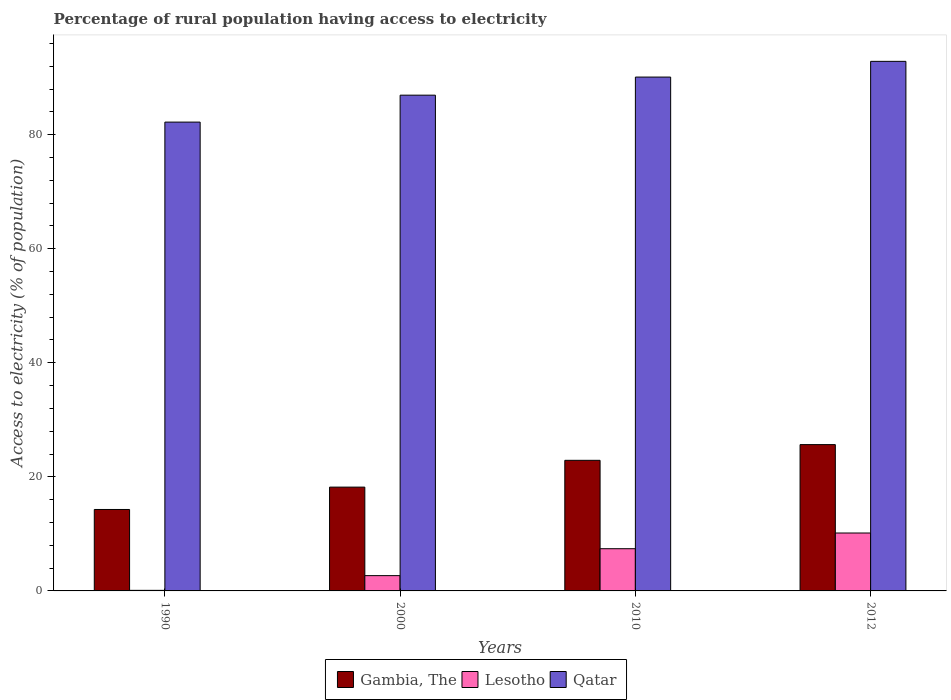How many bars are there on the 2nd tick from the left?
Offer a terse response. 3. How many bars are there on the 4th tick from the right?
Give a very brief answer. 3. Across all years, what is the maximum percentage of rural population having access to electricity in Qatar?
Offer a terse response. 92.85. Across all years, what is the minimum percentage of rural population having access to electricity in Qatar?
Ensure brevity in your answer.  82.2. In which year was the percentage of rural population having access to electricity in Lesotho maximum?
Keep it short and to the point. 2012. In which year was the percentage of rural population having access to electricity in Qatar minimum?
Keep it short and to the point. 1990. What is the total percentage of rural population having access to electricity in Gambia, The in the graph?
Give a very brief answer. 81.03. What is the difference between the percentage of rural population having access to electricity in Gambia, The in 2000 and that in 2010?
Your answer should be compact. -4.7. What is the difference between the percentage of rural population having access to electricity in Gambia, The in 2000 and the percentage of rural population having access to electricity in Lesotho in 2010?
Provide a succinct answer. 10.8. What is the average percentage of rural population having access to electricity in Gambia, The per year?
Ensure brevity in your answer.  20.26. In the year 1990, what is the difference between the percentage of rural population having access to electricity in Qatar and percentage of rural population having access to electricity in Gambia, The?
Offer a very short reply. 67.92. What is the ratio of the percentage of rural population having access to electricity in Lesotho in 1990 to that in 2010?
Your answer should be very brief. 0.01. Is the difference between the percentage of rural population having access to electricity in Qatar in 1990 and 2010 greater than the difference between the percentage of rural population having access to electricity in Gambia, The in 1990 and 2010?
Give a very brief answer. Yes. What is the difference between the highest and the second highest percentage of rural population having access to electricity in Qatar?
Provide a succinct answer. 2.75. What is the difference between the highest and the lowest percentage of rural population having access to electricity in Qatar?
Your answer should be very brief. 10.65. In how many years, is the percentage of rural population having access to electricity in Gambia, The greater than the average percentage of rural population having access to electricity in Gambia, The taken over all years?
Your answer should be compact. 2. What does the 1st bar from the left in 2012 represents?
Keep it short and to the point. Gambia, The. What does the 1st bar from the right in 2000 represents?
Make the answer very short. Qatar. Is it the case that in every year, the sum of the percentage of rural population having access to electricity in Lesotho and percentage of rural population having access to electricity in Qatar is greater than the percentage of rural population having access to electricity in Gambia, The?
Your answer should be very brief. Yes. How many bars are there?
Make the answer very short. 12. Does the graph contain grids?
Provide a short and direct response. No. Where does the legend appear in the graph?
Provide a short and direct response. Bottom center. What is the title of the graph?
Your answer should be very brief. Percentage of rural population having access to electricity. Does "Chad" appear as one of the legend labels in the graph?
Offer a terse response. No. What is the label or title of the Y-axis?
Make the answer very short. Access to electricity (% of population). What is the Access to electricity (% of population) of Gambia, The in 1990?
Ensure brevity in your answer.  14.28. What is the Access to electricity (% of population) of Lesotho in 1990?
Provide a succinct answer. 0.1. What is the Access to electricity (% of population) in Qatar in 1990?
Your response must be concise. 82.2. What is the Access to electricity (% of population) in Gambia, The in 2000?
Keep it short and to the point. 18.2. What is the Access to electricity (% of population) in Lesotho in 2000?
Your answer should be compact. 2.68. What is the Access to electricity (% of population) of Qatar in 2000?
Make the answer very short. 86.93. What is the Access to electricity (% of population) of Gambia, The in 2010?
Give a very brief answer. 22.9. What is the Access to electricity (% of population) in Lesotho in 2010?
Provide a succinct answer. 7.4. What is the Access to electricity (% of population) in Qatar in 2010?
Make the answer very short. 90.1. What is the Access to electricity (% of population) in Gambia, The in 2012?
Ensure brevity in your answer.  25.65. What is the Access to electricity (% of population) of Lesotho in 2012?
Offer a terse response. 10.15. What is the Access to electricity (% of population) of Qatar in 2012?
Your answer should be compact. 92.85. Across all years, what is the maximum Access to electricity (% of population) of Gambia, The?
Give a very brief answer. 25.65. Across all years, what is the maximum Access to electricity (% of population) in Lesotho?
Provide a succinct answer. 10.15. Across all years, what is the maximum Access to electricity (% of population) in Qatar?
Your answer should be very brief. 92.85. Across all years, what is the minimum Access to electricity (% of population) in Gambia, The?
Provide a short and direct response. 14.28. Across all years, what is the minimum Access to electricity (% of population) of Lesotho?
Offer a very short reply. 0.1. Across all years, what is the minimum Access to electricity (% of population) of Qatar?
Ensure brevity in your answer.  82.2. What is the total Access to electricity (% of population) of Gambia, The in the graph?
Keep it short and to the point. 81.03. What is the total Access to electricity (% of population) in Lesotho in the graph?
Keep it short and to the point. 20.34. What is the total Access to electricity (% of population) of Qatar in the graph?
Ensure brevity in your answer.  352.08. What is the difference between the Access to electricity (% of population) of Gambia, The in 1990 and that in 2000?
Keep it short and to the point. -3.92. What is the difference between the Access to electricity (% of population) in Lesotho in 1990 and that in 2000?
Ensure brevity in your answer.  -2.58. What is the difference between the Access to electricity (% of population) of Qatar in 1990 and that in 2000?
Ensure brevity in your answer.  -4.72. What is the difference between the Access to electricity (% of population) of Gambia, The in 1990 and that in 2010?
Your response must be concise. -8.62. What is the difference between the Access to electricity (% of population) in Qatar in 1990 and that in 2010?
Your answer should be compact. -7.9. What is the difference between the Access to electricity (% of population) in Gambia, The in 1990 and that in 2012?
Keep it short and to the point. -11.38. What is the difference between the Access to electricity (% of population) in Lesotho in 1990 and that in 2012?
Keep it short and to the point. -10.05. What is the difference between the Access to electricity (% of population) in Qatar in 1990 and that in 2012?
Your answer should be compact. -10.65. What is the difference between the Access to electricity (% of population) in Gambia, The in 2000 and that in 2010?
Offer a terse response. -4.7. What is the difference between the Access to electricity (% of population) of Lesotho in 2000 and that in 2010?
Ensure brevity in your answer.  -4.72. What is the difference between the Access to electricity (% of population) in Qatar in 2000 and that in 2010?
Keep it short and to the point. -3.17. What is the difference between the Access to electricity (% of population) of Gambia, The in 2000 and that in 2012?
Make the answer very short. -7.45. What is the difference between the Access to electricity (% of population) of Lesotho in 2000 and that in 2012?
Offer a very short reply. -7.47. What is the difference between the Access to electricity (% of population) of Qatar in 2000 and that in 2012?
Provide a short and direct response. -5.93. What is the difference between the Access to electricity (% of population) of Gambia, The in 2010 and that in 2012?
Provide a short and direct response. -2.75. What is the difference between the Access to electricity (% of population) of Lesotho in 2010 and that in 2012?
Make the answer very short. -2.75. What is the difference between the Access to electricity (% of population) of Qatar in 2010 and that in 2012?
Offer a very short reply. -2.75. What is the difference between the Access to electricity (% of population) of Gambia, The in 1990 and the Access to electricity (% of population) of Lesotho in 2000?
Give a very brief answer. 11.6. What is the difference between the Access to electricity (% of population) of Gambia, The in 1990 and the Access to electricity (% of population) of Qatar in 2000?
Give a very brief answer. -72.65. What is the difference between the Access to electricity (% of population) of Lesotho in 1990 and the Access to electricity (% of population) of Qatar in 2000?
Ensure brevity in your answer.  -86.83. What is the difference between the Access to electricity (% of population) in Gambia, The in 1990 and the Access to electricity (% of population) in Lesotho in 2010?
Provide a short and direct response. 6.88. What is the difference between the Access to electricity (% of population) in Gambia, The in 1990 and the Access to electricity (% of population) in Qatar in 2010?
Make the answer very short. -75.82. What is the difference between the Access to electricity (% of population) in Lesotho in 1990 and the Access to electricity (% of population) in Qatar in 2010?
Your answer should be very brief. -90. What is the difference between the Access to electricity (% of population) in Gambia, The in 1990 and the Access to electricity (% of population) in Lesotho in 2012?
Your answer should be very brief. 4.12. What is the difference between the Access to electricity (% of population) of Gambia, The in 1990 and the Access to electricity (% of population) of Qatar in 2012?
Give a very brief answer. -78.58. What is the difference between the Access to electricity (% of population) of Lesotho in 1990 and the Access to electricity (% of population) of Qatar in 2012?
Offer a very short reply. -92.75. What is the difference between the Access to electricity (% of population) of Gambia, The in 2000 and the Access to electricity (% of population) of Qatar in 2010?
Make the answer very short. -71.9. What is the difference between the Access to electricity (% of population) in Lesotho in 2000 and the Access to electricity (% of population) in Qatar in 2010?
Ensure brevity in your answer.  -87.42. What is the difference between the Access to electricity (% of population) in Gambia, The in 2000 and the Access to electricity (% of population) in Lesotho in 2012?
Offer a terse response. 8.05. What is the difference between the Access to electricity (% of population) of Gambia, The in 2000 and the Access to electricity (% of population) of Qatar in 2012?
Your response must be concise. -74.65. What is the difference between the Access to electricity (% of population) in Lesotho in 2000 and the Access to electricity (% of population) in Qatar in 2012?
Your answer should be very brief. -90.17. What is the difference between the Access to electricity (% of population) of Gambia, The in 2010 and the Access to electricity (% of population) of Lesotho in 2012?
Make the answer very short. 12.75. What is the difference between the Access to electricity (% of population) in Gambia, The in 2010 and the Access to electricity (% of population) in Qatar in 2012?
Give a very brief answer. -69.95. What is the difference between the Access to electricity (% of population) in Lesotho in 2010 and the Access to electricity (% of population) in Qatar in 2012?
Keep it short and to the point. -85.45. What is the average Access to electricity (% of population) of Gambia, The per year?
Your answer should be very brief. 20.26. What is the average Access to electricity (% of population) of Lesotho per year?
Make the answer very short. 5.08. What is the average Access to electricity (% of population) in Qatar per year?
Provide a short and direct response. 88.02. In the year 1990, what is the difference between the Access to electricity (% of population) of Gambia, The and Access to electricity (% of population) of Lesotho?
Your answer should be compact. 14.18. In the year 1990, what is the difference between the Access to electricity (% of population) in Gambia, The and Access to electricity (% of population) in Qatar?
Offer a terse response. -67.92. In the year 1990, what is the difference between the Access to electricity (% of population) in Lesotho and Access to electricity (% of population) in Qatar?
Offer a terse response. -82.1. In the year 2000, what is the difference between the Access to electricity (% of population) in Gambia, The and Access to electricity (% of population) in Lesotho?
Make the answer very short. 15.52. In the year 2000, what is the difference between the Access to electricity (% of population) in Gambia, The and Access to electricity (% of population) in Qatar?
Offer a very short reply. -68.73. In the year 2000, what is the difference between the Access to electricity (% of population) in Lesotho and Access to electricity (% of population) in Qatar?
Give a very brief answer. -84.25. In the year 2010, what is the difference between the Access to electricity (% of population) in Gambia, The and Access to electricity (% of population) in Lesotho?
Give a very brief answer. 15.5. In the year 2010, what is the difference between the Access to electricity (% of population) of Gambia, The and Access to electricity (% of population) of Qatar?
Provide a succinct answer. -67.2. In the year 2010, what is the difference between the Access to electricity (% of population) in Lesotho and Access to electricity (% of population) in Qatar?
Offer a terse response. -82.7. In the year 2012, what is the difference between the Access to electricity (% of population) in Gambia, The and Access to electricity (% of population) in Qatar?
Ensure brevity in your answer.  -67.2. In the year 2012, what is the difference between the Access to electricity (% of population) of Lesotho and Access to electricity (% of population) of Qatar?
Keep it short and to the point. -82.7. What is the ratio of the Access to electricity (% of population) in Gambia, The in 1990 to that in 2000?
Make the answer very short. 0.78. What is the ratio of the Access to electricity (% of population) of Lesotho in 1990 to that in 2000?
Ensure brevity in your answer.  0.04. What is the ratio of the Access to electricity (% of population) in Qatar in 1990 to that in 2000?
Give a very brief answer. 0.95. What is the ratio of the Access to electricity (% of population) in Gambia, The in 1990 to that in 2010?
Offer a terse response. 0.62. What is the ratio of the Access to electricity (% of population) in Lesotho in 1990 to that in 2010?
Provide a short and direct response. 0.01. What is the ratio of the Access to electricity (% of population) of Qatar in 1990 to that in 2010?
Offer a very short reply. 0.91. What is the ratio of the Access to electricity (% of population) in Gambia, The in 1990 to that in 2012?
Offer a terse response. 0.56. What is the ratio of the Access to electricity (% of population) of Lesotho in 1990 to that in 2012?
Provide a succinct answer. 0.01. What is the ratio of the Access to electricity (% of population) of Qatar in 1990 to that in 2012?
Your response must be concise. 0.89. What is the ratio of the Access to electricity (% of population) in Gambia, The in 2000 to that in 2010?
Ensure brevity in your answer.  0.79. What is the ratio of the Access to electricity (% of population) in Lesotho in 2000 to that in 2010?
Offer a terse response. 0.36. What is the ratio of the Access to electricity (% of population) in Qatar in 2000 to that in 2010?
Your response must be concise. 0.96. What is the ratio of the Access to electricity (% of population) of Gambia, The in 2000 to that in 2012?
Provide a succinct answer. 0.71. What is the ratio of the Access to electricity (% of population) in Lesotho in 2000 to that in 2012?
Provide a short and direct response. 0.26. What is the ratio of the Access to electricity (% of population) of Qatar in 2000 to that in 2012?
Provide a succinct answer. 0.94. What is the ratio of the Access to electricity (% of population) in Gambia, The in 2010 to that in 2012?
Make the answer very short. 0.89. What is the ratio of the Access to electricity (% of population) of Lesotho in 2010 to that in 2012?
Make the answer very short. 0.73. What is the ratio of the Access to electricity (% of population) in Qatar in 2010 to that in 2012?
Provide a short and direct response. 0.97. What is the difference between the highest and the second highest Access to electricity (% of population) in Gambia, The?
Ensure brevity in your answer.  2.75. What is the difference between the highest and the second highest Access to electricity (% of population) of Lesotho?
Make the answer very short. 2.75. What is the difference between the highest and the second highest Access to electricity (% of population) of Qatar?
Offer a very short reply. 2.75. What is the difference between the highest and the lowest Access to electricity (% of population) of Gambia, The?
Make the answer very short. 11.38. What is the difference between the highest and the lowest Access to electricity (% of population) in Lesotho?
Give a very brief answer. 10.05. What is the difference between the highest and the lowest Access to electricity (% of population) of Qatar?
Your answer should be compact. 10.65. 